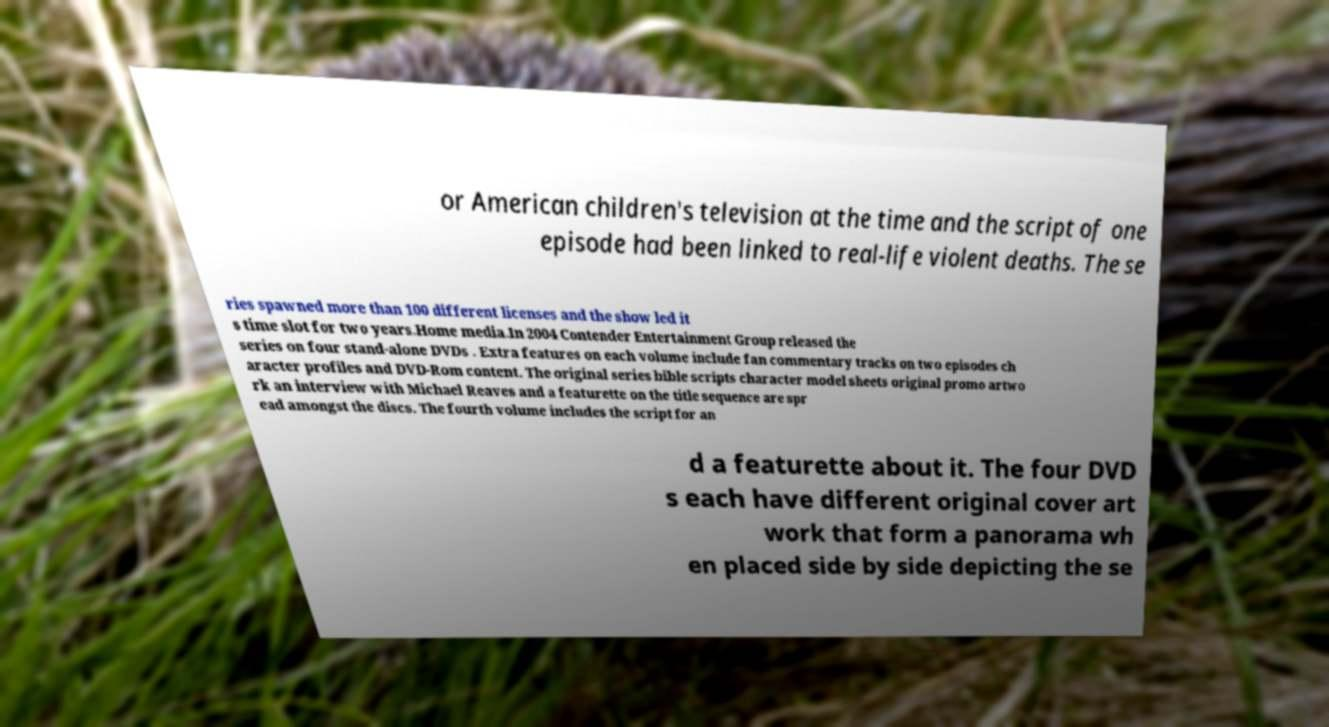What messages or text are displayed in this image? I need them in a readable, typed format. or American children's television at the time and the script of one episode had been linked to real-life violent deaths. The se ries spawned more than 100 different licenses and the show led it s time slot for two years.Home media.In 2004 Contender Entertainment Group released the series on four stand-alone DVDs . Extra features on each volume include fan commentary tracks on two episodes ch aracter profiles and DVD-Rom content. The original series bible scripts character model sheets original promo artwo rk an interview with Michael Reaves and a featurette on the title sequence are spr ead amongst the discs. The fourth volume includes the script for an d a featurette about it. The four DVD s each have different original cover art work that form a panorama wh en placed side by side depicting the se 